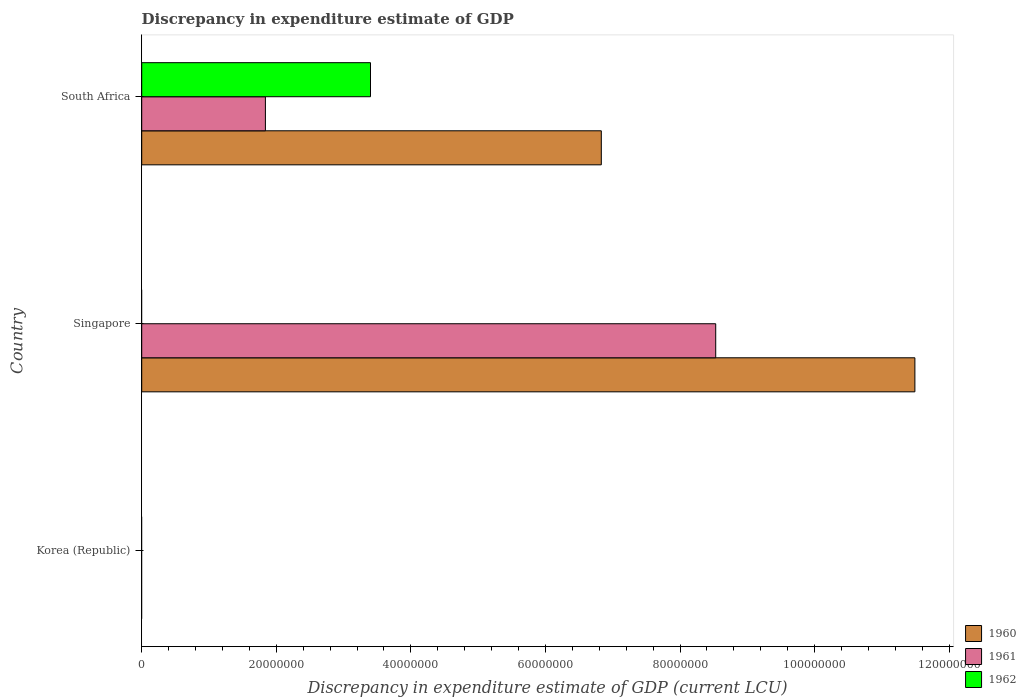How many different coloured bars are there?
Provide a short and direct response. 3. Are the number of bars per tick equal to the number of legend labels?
Offer a terse response. No. How many bars are there on the 2nd tick from the top?
Give a very brief answer. 2. How many bars are there on the 1st tick from the bottom?
Provide a succinct answer. 0. What is the discrepancy in expenditure estimate of GDP in 1960 in Singapore?
Your answer should be compact. 1.15e+08. Across all countries, what is the maximum discrepancy in expenditure estimate of GDP in 1960?
Ensure brevity in your answer.  1.15e+08. Across all countries, what is the minimum discrepancy in expenditure estimate of GDP in 1960?
Give a very brief answer. 0. In which country was the discrepancy in expenditure estimate of GDP in 1962 maximum?
Offer a very short reply. South Africa. What is the total discrepancy in expenditure estimate of GDP in 1962 in the graph?
Keep it short and to the point. 3.40e+07. What is the difference between the discrepancy in expenditure estimate of GDP in 1960 in Singapore and that in South Africa?
Your answer should be very brief. 4.66e+07. What is the difference between the discrepancy in expenditure estimate of GDP in 1960 in South Africa and the discrepancy in expenditure estimate of GDP in 1961 in Singapore?
Ensure brevity in your answer.  -1.70e+07. What is the average discrepancy in expenditure estimate of GDP in 1960 per country?
Offer a very short reply. 6.11e+07. What is the difference between the discrepancy in expenditure estimate of GDP in 1960 and discrepancy in expenditure estimate of GDP in 1961 in Singapore?
Keep it short and to the point. 2.96e+07. What is the ratio of the discrepancy in expenditure estimate of GDP in 1960 in Singapore to that in South Africa?
Your answer should be very brief. 1.68. Is the difference between the discrepancy in expenditure estimate of GDP in 1960 in Singapore and South Africa greater than the difference between the discrepancy in expenditure estimate of GDP in 1961 in Singapore and South Africa?
Offer a terse response. No. What is the difference between the highest and the lowest discrepancy in expenditure estimate of GDP in 1962?
Make the answer very short. 3.40e+07. In how many countries, is the discrepancy in expenditure estimate of GDP in 1962 greater than the average discrepancy in expenditure estimate of GDP in 1962 taken over all countries?
Your answer should be very brief. 1. How many bars are there?
Your answer should be very brief. 5. Are all the bars in the graph horizontal?
Provide a succinct answer. Yes. How many countries are there in the graph?
Offer a terse response. 3. What is the difference between two consecutive major ticks on the X-axis?
Keep it short and to the point. 2.00e+07. Are the values on the major ticks of X-axis written in scientific E-notation?
Your answer should be very brief. No. Does the graph contain grids?
Provide a short and direct response. No. How many legend labels are there?
Your response must be concise. 3. How are the legend labels stacked?
Give a very brief answer. Vertical. What is the title of the graph?
Your answer should be compact. Discrepancy in expenditure estimate of GDP. What is the label or title of the X-axis?
Make the answer very short. Discrepancy in expenditure estimate of GDP (current LCU). What is the Discrepancy in expenditure estimate of GDP (current LCU) in 1961 in Korea (Republic)?
Give a very brief answer. 0. What is the Discrepancy in expenditure estimate of GDP (current LCU) of 1960 in Singapore?
Give a very brief answer. 1.15e+08. What is the Discrepancy in expenditure estimate of GDP (current LCU) of 1961 in Singapore?
Provide a succinct answer. 8.53e+07. What is the Discrepancy in expenditure estimate of GDP (current LCU) in 1960 in South Africa?
Your response must be concise. 6.83e+07. What is the Discrepancy in expenditure estimate of GDP (current LCU) of 1961 in South Africa?
Ensure brevity in your answer.  1.84e+07. What is the Discrepancy in expenditure estimate of GDP (current LCU) in 1962 in South Africa?
Keep it short and to the point. 3.40e+07. Across all countries, what is the maximum Discrepancy in expenditure estimate of GDP (current LCU) in 1960?
Provide a succinct answer. 1.15e+08. Across all countries, what is the maximum Discrepancy in expenditure estimate of GDP (current LCU) of 1961?
Your answer should be very brief. 8.53e+07. Across all countries, what is the maximum Discrepancy in expenditure estimate of GDP (current LCU) in 1962?
Make the answer very short. 3.40e+07. Across all countries, what is the minimum Discrepancy in expenditure estimate of GDP (current LCU) of 1960?
Your answer should be very brief. 0. Across all countries, what is the minimum Discrepancy in expenditure estimate of GDP (current LCU) of 1961?
Your response must be concise. 0. Across all countries, what is the minimum Discrepancy in expenditure estimate of GDP (current LCU) in 1962?
Give a very brief answer. 0. What is the total Discrepancy in expenditure estimate of GDP (current LCU) in 1960 in the graph?
Ensure brevity in your answer.  1.83e+08. What is the total Discrepancy in expenditure estimate of GDP (current LCU) in 1961 in the graph?
Offer a very short reply. 1.04e+08. What is the total Discrepancy in expenditure estimate of GDP (current LCU) in 1962 in the graph?
Provide a short and direct response. 3.40e+07. What is the difference between the Discrepancy in expenditure estimate of GDP (current LCU) of 1960 in Singapore and that in South Africa?
Provide a succinct answer. 4.66e+07. What is the difference between the Discrepancy in expenditure estimate of GDP (current LCU) of 1961 in Singapore and that in South Africa?
Keep it short and to the point. 6.69e+07. What is the difference between the Discrepancy in expenditure estimate of GDP (current LCU) of 1960 in Singapore and the Discrepancy in expenditure estimate of GDP (current LCU) of 1961 in South Africa?
Give a very brief answer. 9.65e+07. What is the difference between the Discrepancy in expenditure estimate of GDP (current LCU) of 1960 in Singapore and the Discrepancy in expenditure estimate of GDP (current LCU) of 1962 in South Africa?
Offer a terse response. 8.09e+07. What is the difference between the Discrepancy in expenditure estimate of GDP (current LCU) of 1961 in Singapore and the Discrepancy in expenditure estimate of GDP (current LCU) of 1962 in South Africa?
Give a very brief answer. 5.13e+07. What is the average Discrepancy in expenditure estimate of GDP (current LCU) of 1960 per country?
Your answer should be very brief. 6.11e+07. What is the average Discrepancy in expenditure estimate of GDP (current LCU) in 1961 per country?
Provide a succinct answer. 3.46e+07. What is the average Discrepancy in expenditure estimate of GDP (current LCU) of 1962 per country?
Give a very brief answer. 1.13e+07. What is the difference between the Discrepancy in expenditure estimate of GDP (current LCU) of 1960 and Discrepancy in expenditure estimate of GDP (current LCU) of 1961 in Singapore?
Your answer should be very brief. 2.96e+07. What is the difference between the Discrepancy in expenditure estimate of GDP (current LCU) of 1960 and Discrepancy in expenditure estimate of GDP (current LCU) of 1961 in South Africa?
Your answer should be compact. 4.99e+07. What is the difference between the Discrepancy in expenditure estimate of GDP (current LCU) in 1960 and Discrepancy in expenditure estimate of GDP (current LCU) in 1962 in South Africa?
Your response must be concise. 3.43e+07. What is the difference between the Discrepancy in expenditure estimate of GDP (current LCU) of 1961 and Discrepancy in expenditure estimate of GDP (current LCU) of 1962 in South Africa?
Make the answer very short. -1.56e+07. What is the ratio of the Discrepancy in expenditure estimate of GDP (current LCU) in 1960 in Singapore to that in South Africa?
Provide a succinct answer. 1.68. What is the ratio of the Discrepancy in expenditure estimate of GDP (current LCU) of 1961 in Singapore to that in South Africa?
Keep it short and to the point. 4.64. What is the difference between the highest and the lowest Discrepancy in expenditure estimate of GDP (current LCU) of 1960?
Keep it short and to the point. 1.15e+08. What is the difference between the highest and the lowest Discrepancy in expenditure estimate of GDP (current LCU) of 1961?
Offer a terse response. 8.53e+07. What is the difference between the highest and the lowest Discrepancy in expenditure estimate of GDP (current LCU) in 1962?
Your response must be concise. 3.40e+07. 